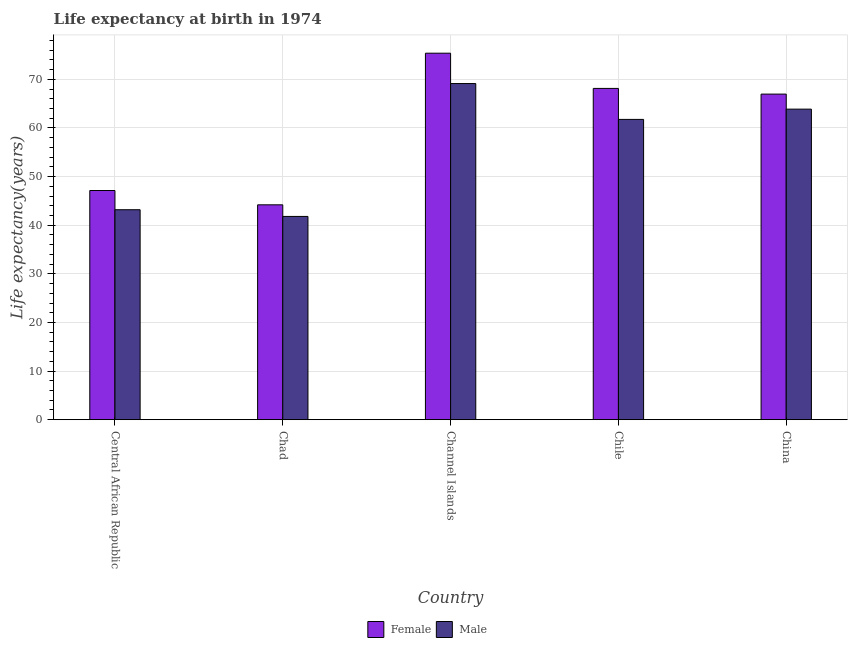How many groups of bars are there?
Your response must be concise. 5. How many bars are there on the 3rd tick from the right?
Offer a terse response. 2. What is the label of the 3rd group of bars from the left?
Keep it short and to the point. Channel Islands. What is the life expectancy(male) in Channel Islands?
Your answer should be very brief. 69.13. Across all countries, what is the maximum life expectancy(female)?
Offer a very short reply. 75.38. Across all countries, what is the minimum life expectancy(female)?
Provide a succinct answer. 44.19. In which country was the life expectancy(male) maximum?
Make the answer very short. Channel Islands. In which country was the life expectancy(male) minimum?
Make the answer very short. Chad. What is the total life expectancy(female) in the graph?
Give a very brief answer. 301.8. What is the difference between the life expectancy(male) in Central African Republic and that in Chad?
Make the answer very short. 1.38. What is the difference between the life expectancy(female) in Chad and the life expectancy(male) in Channel Islands?
Provide a succinct answer. -24.94. What is the average life expectancy(male) per country?
Provide a succinct answer. 55.95. What is the difference between the life expectancy(male) and life expectancy(female) in Channel Islands?
Offer a very short reply. -6.24. In how many countries, is the life expectancy(male) greater than 8 years?
Make the answer very short. 5. What is the ratio of the life expectancy(male) in Channel Islands to that in Chile?
Offer a very short reply. 1.12. Is the life expectancy(female) in Central African Republic less than that in Chile?
Give a very brief answer. Yes. Is the difference between the life expectancy(male) in Channel Islands and China greater than the difference between the life expectancy(female) in Channel Islands and China?
Offer a terse response. No. What is the difference between the highest and the second highest life expectancy(female)?
Keep it short and to the point. 7.24. What is the difference between the highest and the lowest life expectancy(female)?
Give a very brief answer. 31.18. Is the sum of the life expectancy(female) in Central African Republic and China greater than the maximum life expectancy(male) across all countries?
Your response must be concise. Yes. Where does the legend appear in the graph?
Your answer should be very brief. Bottom center. How many legend labels are there?
Your response must be concise. 2. What is the title of the graph?
Offer a very short reply. Life expectancy at birth in 1974. Does "Lower secondary rate" appear as one of the legend labels in the graph?
Your answer should be very brief. No. What is the label or title of the Y-axis?
Provide a short and direct response. Life expectancy(years). What is the Life expectancy(years) of Female in Central African Republic?
Offer a very short reply. 47.14. What is the Life expectancy(years) in Male in Central African Republic?
Offer a very short reply. 43.18. What is the Life expectancy(years) of Female in Chad?
Offer a terse response. 44.19. What is the Life expectancy(years) in Male in Chad?
Offer a terse response. 41.8. What is the Life expectancy(years) of Female in Channel Islands?
Make the answer very short. 75.38. What is the Life expectancy(years) of Male in Channel Islands?
Provide a succinct answer. 69.13. What is the Life expectancy(years) in Female in Chile?
Provide a succinct answer. 68.13. What is the Life expectancy(years) in Male in Chile?
Make the answer very short. 61.76. What is the Life expectancy(years) of Female in China?
Your response must be concise. 66.96. What is the Life expectancy(years) of Male in China?
Offer a very short reply. 63.87. Across all countries, what is the maximum Life expectancy(years) of Female?
Your answer should be very brief. 75.38. Across all countries, what is the maximum Life expectancy(years) in Male?
Make the answer very short. 69.13. Across all countries, what is the minimum Life expectancy(years) of Female?
Make the answer very short. 44.19. Across all countries, what is the minimum Life expectancy(years) in Male?
Offer a very short reply. 41.8. What is the total Life expectancy(years) in Female in the graph?
Your answer should be very brief. 301.8. What is the total Life expectancy(years) in Male in the graph?
Provide a succinct answer. 279.75. What is the difference between the Life expectancy(years) in Female in Central African Republic and that in Chad?
Offer a very short reply. 2.95. What is the difference between the Life expectancy(years) in Male in Central African Republic and that in Chad?
Make the answer very short. 1.38. What is the difference between the Life expectancy(years) of Female in Central African Republic and that in Channel Islands?
Your answer should be very brief. -28.24. What is the difference between the Life expectancy(years) of Male in Central African Republic and that in Channel Islands?
Your response must be concise. -25.95. What is the difference between the Life expectancy(years) in Female in Central African Republic and that in Chile?
Offer a very short reply. -21. What is the difference between the Life expectancy(years) of Male in Central African Republic and that in Chile?
Provide a succinct answer. -18.58. What is the difference between the Life expectancy(years) in Female in Central African Republic and that in China?
Offer a very short reply. -19.83. What is the difference between the Life expectancy(years) in Male in Central African Republic and that in China?
Give a very brief answer. -20.69. What is the difference between the Life expectancy(years) of Female in Chad and that in Channel Islands?
Your answer should be very brief. -31.18. What is the difference between the Life expectancy(years) of Male in Chad and that in Channel Islands?
Give a very brief answer. -27.33. What is the difference between the Life expectancy(years) in Female in Chad and that in Chile?
Your response must be concise. -23.94. What is the difference between the Life expectancy(years) in Male in Chad and that in Chile?
Offer a very short reply. -19.96. What is the difference between the Life expectancy(years) in Female in Chad and that in China?
Provide a succinct answer. -22.77. What is the difference between the Life expectancy(years) of Male in Chad and that in China?
Your answer should be very brief. -22.07. What is the difference between the Life expectancy(years) of Female in Channel Islands and that in Chile?
Provide a succinct answer. 7.24. What is the difference between the Life expectancy(years) of Male in Channel Islands and that in Chile?
Your answer should be very brief. 7.37. What is the difference between the Life expectancy(years) in Female in Channel Islands and that in China?
Keep it short and to the point. 8.41. What is the difference between the Life expectancy(years) in Male in Channel Islands and that in China?
Provide a short and direct response. 5.26. What is the difference between the Life expectancy(years) in Female in Chile and that in China?
Keep it short and to the point. 1.17. What is the difference between the Life expectancy(years) of Male in Chile and that in China?
Your answer should be very brief. -2.11. What is the difference between the Life expectancy(years) of Female in Central African Republic and the Life expectancy(years) of Male in Chad?
Give a very brief answer. 5.33. What is the difference between the Life expectancy(years) of Female in Central African Republic and the Life expectancy(years) of Male in Channel Islands?
Your answer should be compact. -22. What is the difference between the Life expectancy(years) in Female in Central African Republic and the Life expectancy(years) in Male in Chile?
Provide a succinct answer. -14.62. What is the difference between the Life expectancy(years) in Female in Central African Republic and the Life expectancy(years) in Male in China?
Your answer should be very brief. -16.73. What is the difference between the Life expectancy(years) in Female in Chad and the Life expectancy(years) in Male in Channel Islands?
Offer a very short reply. -24.94. What is the difference between the Life expectancy(years) of Female in Chad and the Life expectancy(years) of Male in Chile?
Give a very brief answer. -17.57. What is the difference between the Life expectancy(years) of Female in Chad and the Life expectancy(years) of Male in China?
Provide a short and direct response. -19.68. What is the difference between the Life expectancy(years) of Female in Channel Islands and the Life expectancy(years) of Male in Chile?
Give a very brief answer. 13.61. What is the difference between the Life expectancy(years) in Female in Channel Islands and the Life expectancy(years) in Male in China?
Ensure brevity in your answer.  11.5. What is the difference between the Life expectancy(years) of Female in Chile and the Life expectancy(years) of Male in China?
Give a very brief answer. 4.26. What is the average Life expectancy(years) in Female per country?
Offer a terse response. 60.36. What is the average Life expectancy(years) of Male per country?
Provide a succinct answer. 55.95. What is the difference between the Life expectancy(years) in Female and Life expectancy(years) in Male in Central African Republic?
Offer a terse response. 3.95. What is the difference between the Life expectancy(years) in Female and Life expectancy(years) in Male in Chad?
Make the answer very short. 2.39. What is the difference between the Life expectancy(years) of Female and Life expectancy(years) of Male in Channel Islands?
Provide a succinct answer. 6.24. What is the difference between the Life expectancy(years) in Female and Life expectancy(years) in Male in Chile?
Provide a succinct answer. 6.37. What is the difference between the Life expectancy(years) of Female and Life expectancy(years) of Male in China?
Your answer should be compact. 3.09. What is the ratio of the Life expectancy(years) of Female in Central African Republic to that in Chad?
Make the answer very short. 1.07. What is the ratio of the Life expectancy(years) of Male in Central African Republic to that in Chad?
Your answer should be compact. 1.03. What is the ratio of the Life expectancy(years) of Female in Central African Republic to that in Channel Islands?
Your response must be concise. 0.63. What is the ratio of the Life expectancy(years) of Male in Central African Republic to that in Channel Islands?
Offer a terse response. 0.62. What is the ratio of the Life expectancy(years) in Female in Central African Republic to that in Chile?
Your answer should be very brief. 0.69. What is the ratio of the Life expectancy(years) in Male in Central African Republic to that in Chile?
Give a very brief answer. 0.7. What is the ratio of the Life expectancy(years) of Female in Central African Republic to that in China?
Make the answer very short. 0.7. What is the ratio of the Life expectancy(years) of Male in Central African Republic to that in China?
Your answer should be very brief. 0.68. What is the ratio of the Life expectancy(years) in Female in Chad to that in Channel Islands?
Make the answer very short. 0.59. What is the ratio of the Life expectancy(years) of Male in Chad to that in Channel Islands?
Provide a short and direct response. 0.6. What is the ratio of the Life expectancy(years) in Female in Chad to that in Chile?
Keep it short and to the point. 0.65. What is the ratio of the Life expectancy(years) in Male in Chad to that in Chile?
Provide a short and direct response. 0.68. What is the ratio of the Life expectancy(years) of Female in Chad to that in China?
Your answer should be very brief. 0.66. What is the ratio of the Life expectancy(years) of Male in Chad to that in China?
Your answer should be very brief. 0.65. What is the ratio of the Life expectancy(years) in Female in Channel Islands to that in Chile?
Offer a very short reply. 1.11. What is the ratio of the Life expectancy(years) in Male in Channel Islands to that in Chile?
Keep it short and to the point. 1.12. What is the ratio of the Life expectancy(years) of Female in Channel Islands to that in China?
Offer a terse response. 1.13. What is the ratio of the Life expectancy(years) in Male in Channel Islands to that in China?
Provide a short and direct response. 1.08. What is the ratio of the Life expectancy(years) of Female in Chile to that in China?
Provide a succinct answer. 1.02. What is the ratio of the Life expectancy(years) of Male in Chile to that in China?
Keep it short and to the point. 0.97. What is the difference between the highest and the second highest Life expectancy(years) in Female?
Provide a succinct answer. 7.24. What is the difference between the highest and the second highest Life expectancy(years) of Male?
Your answer should be very brief. 5.26. What is the difference between the highest and the lowest Life expectancy(years) in Female?
Keep it short and to the point. 31.18. What is the difference between the highest and the lowest Life expectancy(years) in Male?
Give a very brief answer. 27.33. 